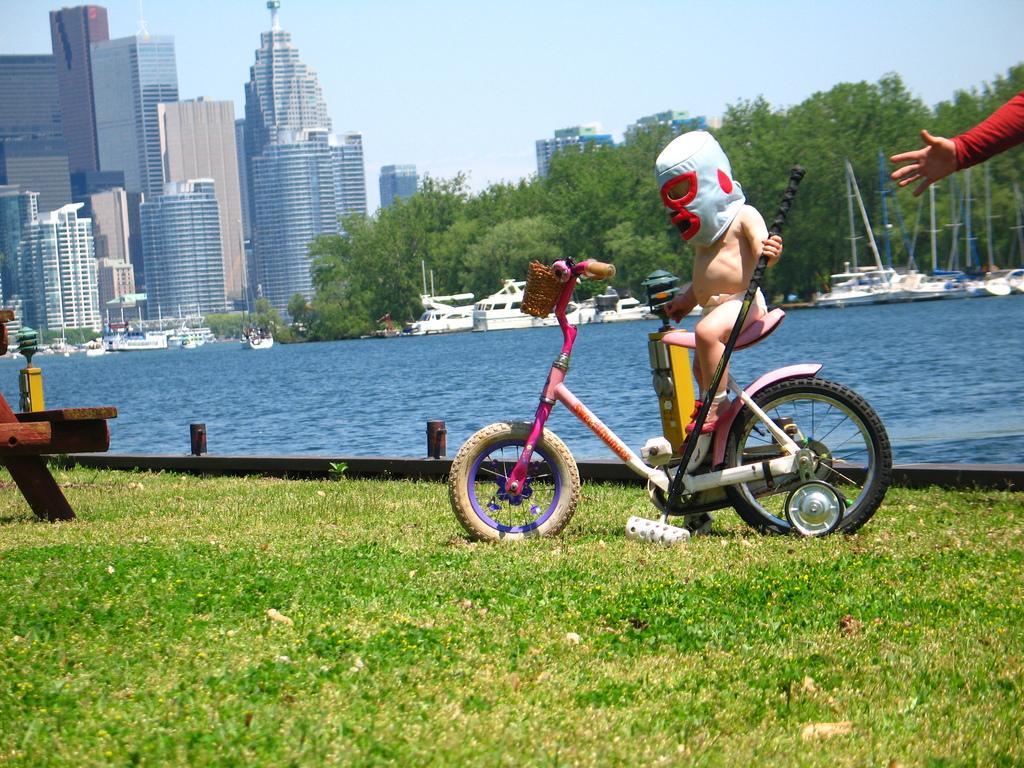In one or two sentences, can you explain what this image depicts? In this image we can see a baby sitting on the bicycle. On the right we can see a person's hand. At the bottom there is grass. In the background we can see water and there are boats on the water. There are trees, buildings and sky. 